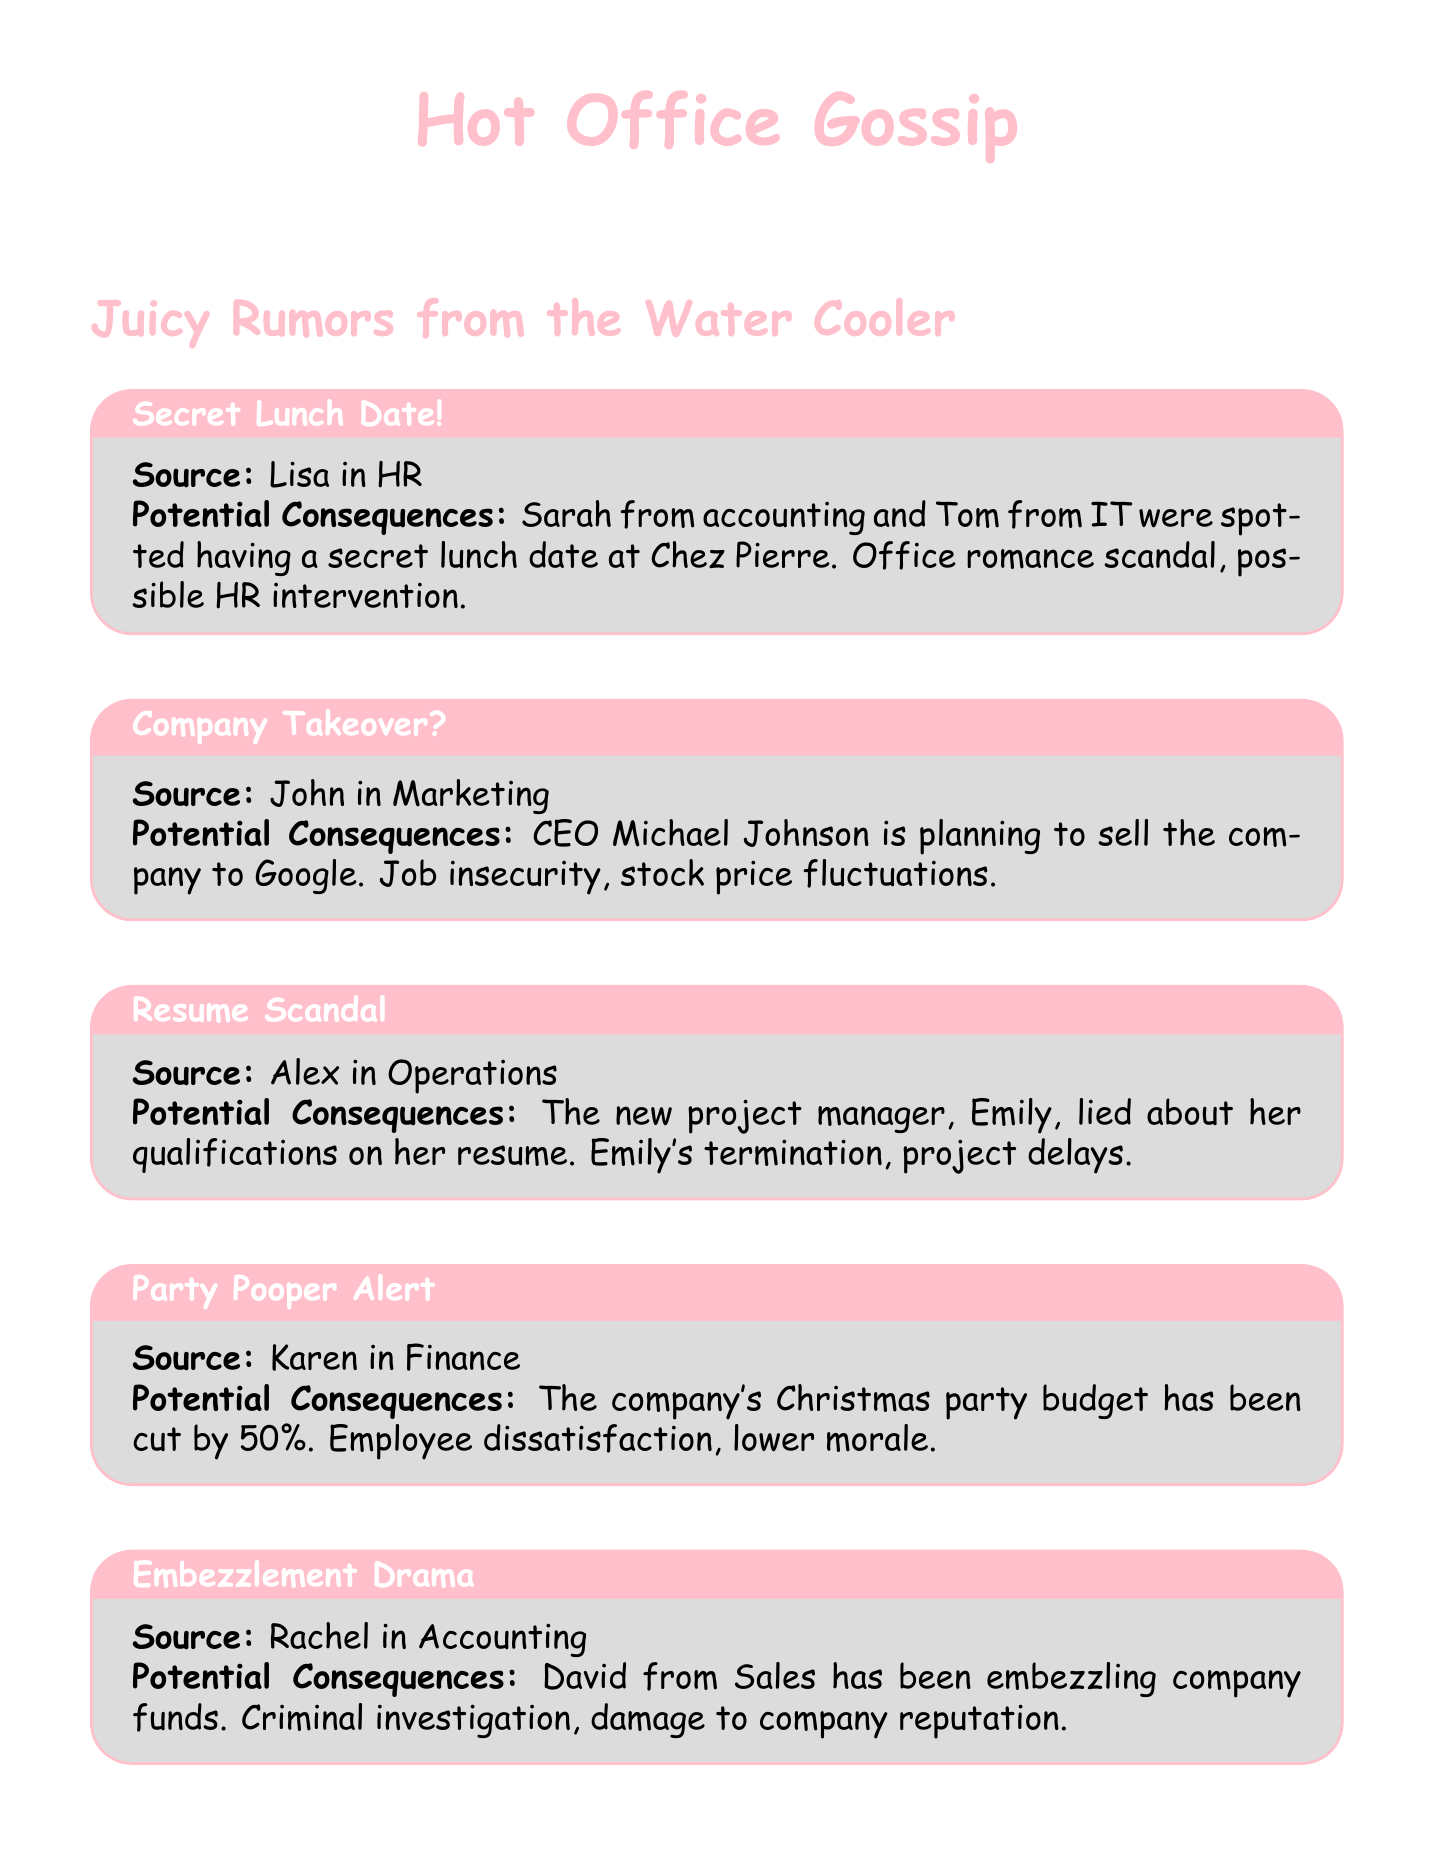What rumor did Lisa in HR share? Lisa in HR shared the rumor about Sarah from accounting and Tom from IT having a secret lunch date at Chez Pierre.
Answer: secret lunch date What are the potential consequences of the rumor about CEO Michael Johnson? The potential consequences include job insecurity and stock price fluctuations.
Answer: Job insecurity, stock price fluctuations Who is accused of lying about qualifications on her resume? The rumor states that the new project manager, Emily, is accused of lying about her qualifications.
Answer: Emily What budget has been cut by 50% according to Karen in Finance? Karen in Finance mentioned that the company's Christmas party budget has been cut by 50%.
Answer: Christmas party budget What is the source of the rumor regarding David from Sales? The source of the rumor about David from Sales embezzling company funds is Rachel in Accounting.
Answer: Rachel in Accounting What might happen to Emily if the rumor about her qualifications is true? If the rumor about Emily's qualifications is true, it could lead to her termination and project delays.
Answer: Emily's termination, project delays What is causing jealousy from other departments? The surprise bonus for the entire Marketing team next month is causing jealousy from other departments.
Answer: Surprise bonus Which department is Mike from? Mike, who shared the rumor about the Marketing team's bonus, is from HR.
Answer: HR 